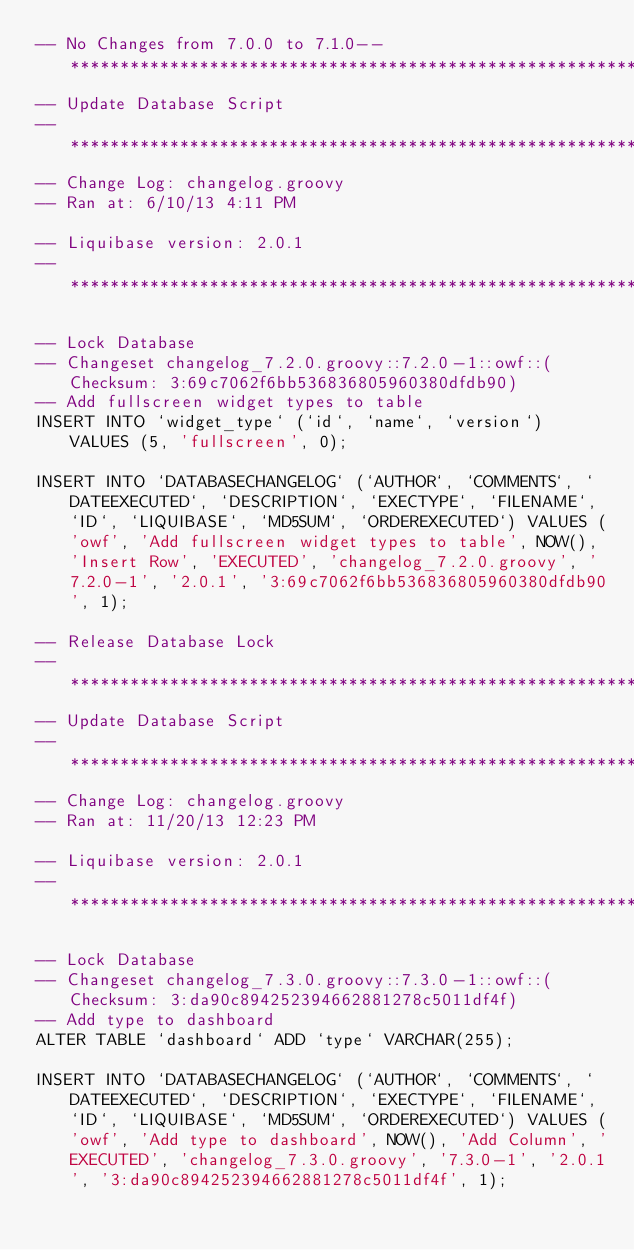Convert code to text. <code><loc_0><loc_0><loc_500><loc_500><_SQL_>-- No Changes from 7.0.0 to 7.1.0-- *********************************************************************
-- Update Database Script
-- *********************************************************************
-- Change Log: changelog.groovy
-- Ran at: 6/10/13 4:11 PM

-- Liquibase version: 2.0.1
-- *********************************************************************

-- Lock Database
-- Changeset changelog_7.2.0.groovy::7.2.0-1::owf::(Checksum: 3:69c7062f6bb536836805960380dfdb90)
-- Add fullscreen widget types to table
INSERT INTO `widget_type` (`id`, `name`, `version`) VALUES (5, 'fullscreen', 0);

INSERT INTO `DATABASECHANGELOG` (`AUTHOR`, `COMMENTS`, `DATEEXECUTED`, `DESCRIPTION`, `EXECTYPE`, `FILENAME`, `ID`, `LIQUIBASE`, `MD5SUM`, `ORDEREXECUTED`) VALUES ('owf', 'Add fullscreen widget types to table', NOW(), 'Insert Row', 'EXECUTED', 'changelog_7.2.0.groovy', '7.2.0-1', '2.0.1', '3:69c7062f6bb536836805960380dfdb90', 1);

-- Release Database Lock
-- *********************************************************************
-- Update Database Script
-- *********************************************************************
-- Change Log: changelog.groovy
-- Ran at: 11/20/13 12:23 PM

-- Liquibase version: 2.0.1
-- *********************************************************************

-- Lock Database
-- Changeset changelog_7.3.0.groovy::7.3.0-1::owf::(Checksum: 3:da90c894252394662881278c5011df4f)
-- Add type to dashboard
ALTER TABLE `dashboard` ADD `type` VARCHAR(255);

INSERT INTO `DATABASECHANGELOG` (`AUTHOR`, `COMMENTS`, `DATEEXECUTED`, `DESCRIPTION`, `EXECTYPE`, `FILENAME`, `ID`, `LIQUIBASE`, `MD5SUM`, `ORDEREXECUTED`) VALUES ('owf', 'Add type to dashboard', NOW(), 'Add Column', 'EXECUTED', 'changelog_7.3.0.groovy', '7.3.0-1', '2.0.1', '3:da90c894252394662881278c5011df4f', 1);
</code> 